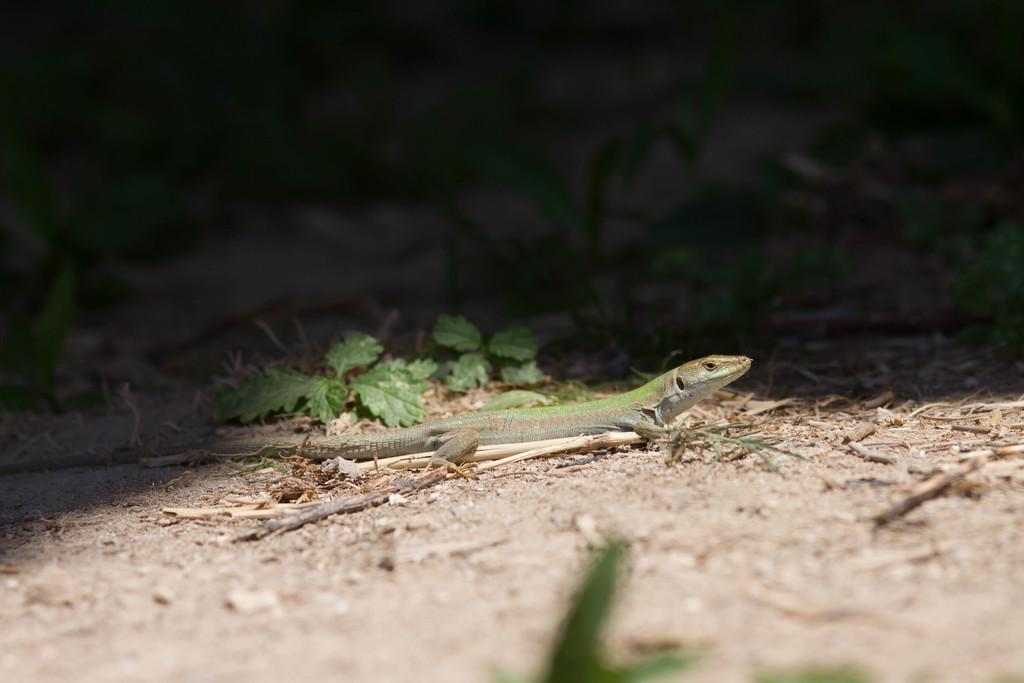What type of animal is in the image? There is a reptile in the image. What can be seen in the background of the image? There are plants in the background of the image. What color are the plants in the image? The plants are green in color. What type of brass instrument is being played by the reptile in the image? There is no brass instrument present in the image, as it only features a reptile and plants. 